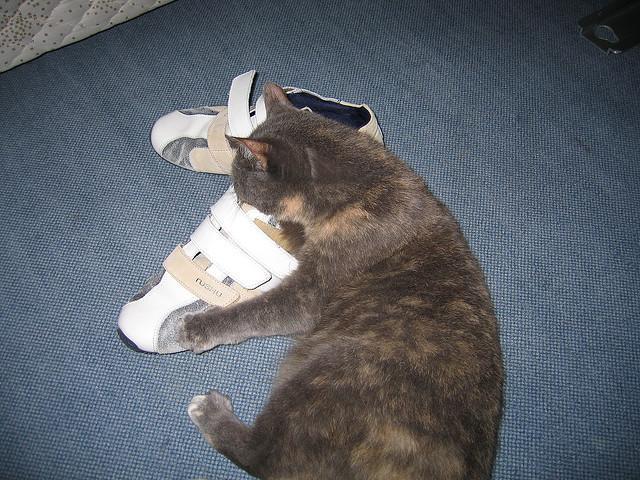How many birds are in the water?
Give a very brief answer. 0. 